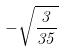<formula> <loc_0><loc_0><loc_500><loc_500>- \sqrt { \frac { 3 } { 3 5 } }</formula> 